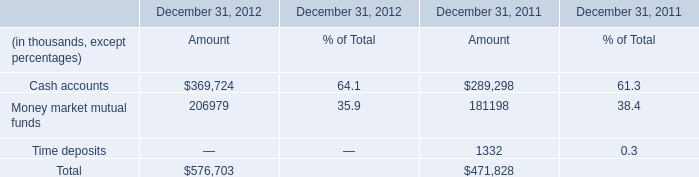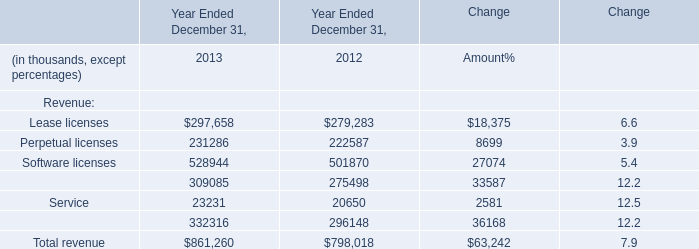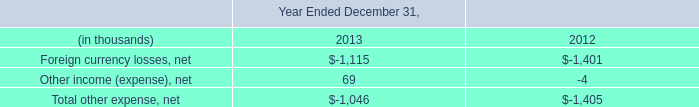What's the 30 % of total elements in 2013? (in thousand) 
Computations: (861260 * 0.3)
Answer: 258378.0. 